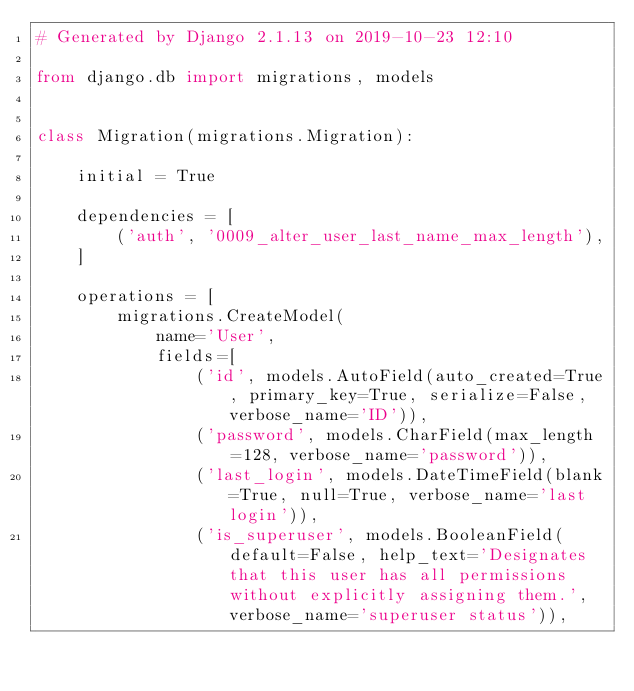Convert code to text. <code><loc_0><loc_0><loc_500><loc_500><_Python_># Generated by Django 2.1.13 on 2019-10-23 12:10

from django.db import migrations, models


class Migration(migrations.Migration):

    initial = True

    dependencies = [
        ('auth', '0009_alter_user_last_name_max_length'),
    ]

    operations = [
        migrations.CreateModel(
            name='User',
            fields=[
                ('id', models.AutoField(auto_created=True, primary_key=True, serialize=False, verbose_name='ID')),
                ('password', models.CharField(max_length=128, verbose_name='password')),
                ('last_login', models.DateTimeField(blank=True, null=True, verbose_name='last login')),
                ('is_superuser', models.BooleanField(default=False, help_text='Designates that this user has all permissions without explicitly assigning them.', verbose_name='superuser status')),</code> 